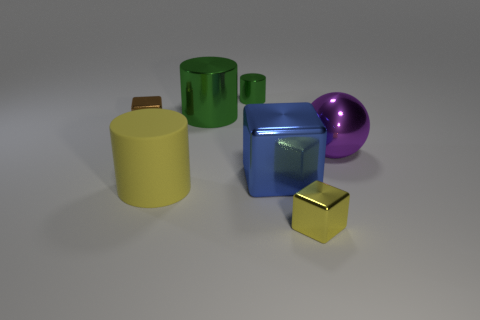Add 1 small cyan cubes. How many objects exist? 8 Subtract all balls. How many objects are left? 6 Add 5 big blue objects. How many big blue objects are left? 6 Add 5 purple balls. How many purple balls exist? 6 Subtract 0 cyan balls. How many objects are left? 7 Subtract all tiny green cylinders. Subtract all brown cubes. How many objects are left? 5 